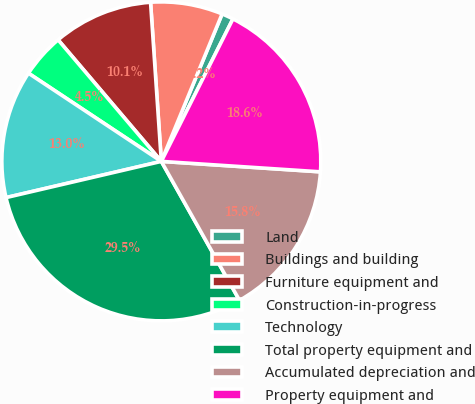Convert chart. <chart><loc_0><loc_0><loc_500><loc_500><pie_chart><fcel>Land<fcel>Buildings and building<fcel>Furniture equipment and<fcel>Construction-in-progress<fcel>Technology<fcel>Total property equipment and<fcel>Accumulated depreciation and<fcel>Property equipment and<nl><fcel>1.19%<fcel>7.3%<fcel>10.13%<fcel>4.47%<fcel>12.97%<fcel>29.51%<fcel>15.8%<fcel>18.63%<nl></chart> 